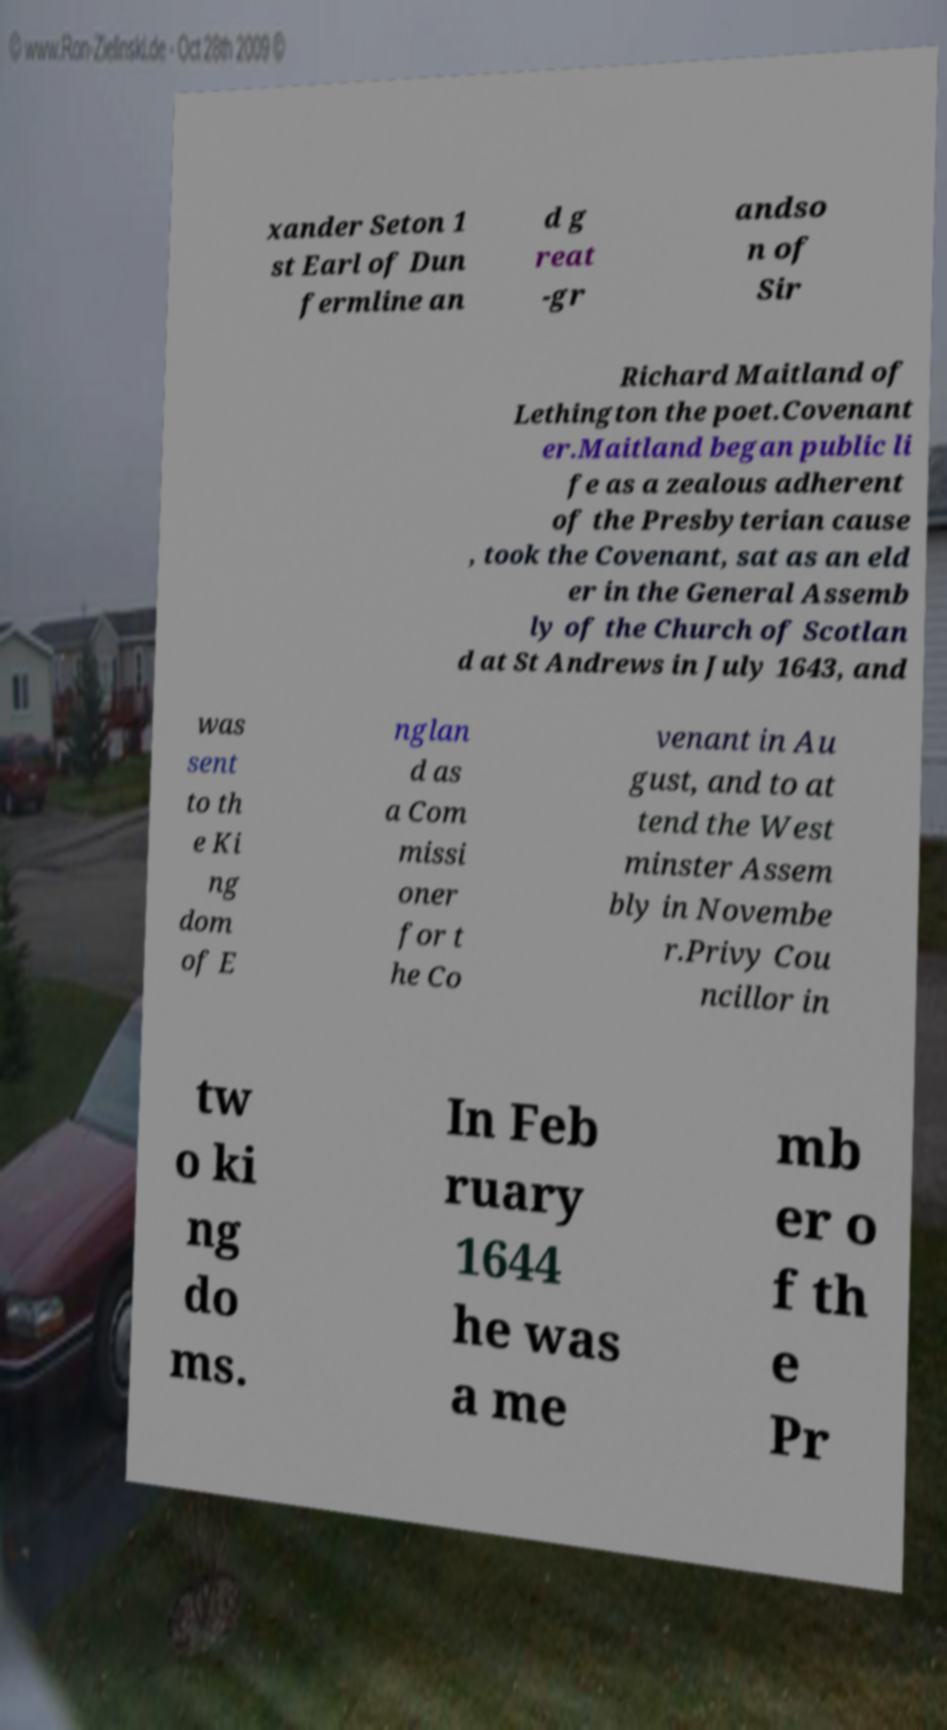There's text embedded in this image that I need extracted. Can you transcribe it verbatim? xander Seton 1 st Earl of Dun fermline an d g reat -gr andso n of Sir Richard Maitland of Lethington the poet.Covenant er.Maitland began public li fe as a zealous adherent of the Presbyterian cause , took the Covenant, sat as an eld er in the General Assemb ly of the Church of Scotlan d at St Andrews in July 1643, and was sent to th e Ki ng dom of E nglan d as a Com missi oner for t he Co venant in Au gust, and to at tend the West minster Assem bly in Novembe r.Privy Cou ncillor in tw o ki ng do ms. In Feb ruary 1644 he was a me mb er o f th e Pr 